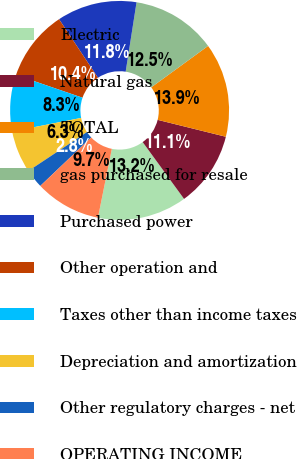<chart> <loc_0><loc_0><loc_500><loc_500><pie_chart><fcel>Electric<fcel>Natural gas<fcel>TOTAL<fcel>gas purchased for resale<fcel>Purchased power<fcel>Other operation and<fcel>Taxes other than income taxes<fcel>Depreciation and amortization<fcel>Other regulatory charges - net<fcel>OPERATING INCOME<nl><fcel>13.19%<fcel>11.11%<fcel>13.89%<fcel>12.5%<fcel>11.8%<fcel>10.42%<fcel>8.33%<fcel>6.25%<fcel>2.78%<fcel>9.72%<nl></chart> 